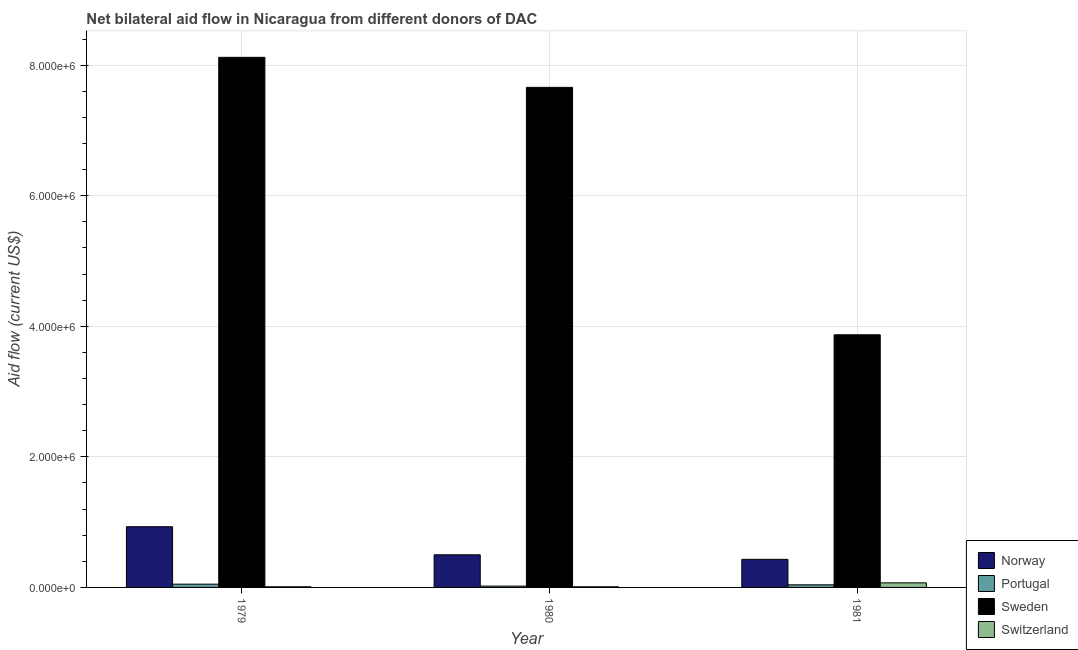Are the number of bars per tick equal to the number of legend labels?
Make the answer very short. Yes. Are the number of bars on each tick of the X-axis equal?
Provide a succinct answer. Yes. How many bars are there on the 1st tick from the left?
Keep it short and to the point. 4. How many bars are there on the 2nd tick from the right?
Keep it short and to the point. 4. What is the label of the 1st group of bars from the left?
Make the answer very short. 1979. In how many cases, is the number of bars for a given year not equal to the number of legend labels?
Provide a short and direct response. 0. What is the amount of aid given by sweden in 1979?
Ensure brevity in your answer.  8.12e+06. Across all years, what is the maximum amount of aid given by sweden?
Provide a short and direct response. 8.12e+06. Across all years, what is the minimum amount of aid given by switzerland?
Make the answer very short. 10000. What is the total amount of aid given by norway in the graph?
Ensure brevity in your answer.  1.86e+06. What is the difference between the amount of aid given by norway in 1979 and that in 1980?
Make the answer very short. 4.30e+05. What is the difference between the amount of aid given by norway in 1979 and the amount of aid given by portugal in 1981?
Make the answer very short. 5.00e+05. What is the average amount of aid given by norway per year?
Your response must be concise. 6.20e+05. In the year 1979, what is the difference between the amount of aid given by sweden and amount of aid given by switzerland?
Give a very brief answer. 0. In how many years, is the amount of aid given by switzerland greater than 7200000 US$?
Keep it short and to the point. 0. What is the ratio of the amount of aid given by portugal in 1979 to that in 1981?
Provide a succinct answer. 1.25. Is the amount of aid given by norway in 1980 less than that in 1981?
Offer a very short reply. No. Is the difference between the amount of aid given by portugal in 1980 and 1981 greater than the difference between the amount of aid given by switzerland in 1980 and 1981?
Give a very brief answer. No. What is the difference between the highest and the second highest amount of aid given by switzerland?
Your answer should be compact. 6.00e+04. What is the difference between the highest and the lowest amount of aid given by switzerland?
Your answer should be very brief. 6.00e+04. What does the 4th bar from the left in 1979 represents?
Your answer should be very brief. Switzerland. What does the 1st bar from the right in 1980 represents?
Ensure brevity in your answer.  Switzerland. How many bars are there?
Your response must be concise. 12. How many years are there in the graph?
Ensure brevity in your answer.  3. Does the graph contain grids?
Your response must be concise. Yes. How many legend labels are there?
Make the answer very short. 4. What is the title of the graph?
Your answer should be compact. Net bilateral aid flow in Nicaragua from different donors of DAC. Does "Public resource use" appear as one of the legend labels in the graph?
Your answer should be compact. No. What is the Aid flow (current US$) of Norway in 1979?
Your answer should be compact. 9.30e+05. What is the Aid flow (current US$) in Portugal in 1979?
Keep it short and to the point. 5.00e+04. What is the Aid flow (current US$) in Sweden in 1979?
Your response must be concise. 8.12e+06. What is the Aid flow (current US$) of Norway in 1980?
Give a very brief answer. 5.00e+05. What is the Aid flow (current US$) of Sweden in 1980?
Your answer should be compact. 7.66e+06. What is the Aid flow (current US$) of Portugal in 1981?
Your answer should be compact. 4.00e+04. What is the Aid flow (current US$) in Sweden in 1981?
Provide a succinct answer. 3.87e+06. Across all years, what is the maximum Aid flow (current US$) of Norway?
Make the answer very short. 9.30e+05. Across all years, what is the maximum Aid flow (current US$) of Sweden?
Provide a short and direct response. 8.12e+06. Across all years, what is the maximum Aid flow (current US$) in Switzerland?
Provide a succinct answer. 7.00e+04. Across all years, what is the minimum Aid flow (current US$) of Norway?
Offer a very short reply. 4.30e+05. Across all years, what is the minimum Aid flow (current US$) of Portugal?
Keep it short and to the point. 2.00e+04. Across all years, what is the minimum Aid flow (current US$) of Sweden?
Your answer should be very brief. 3.87e+06. Across all years, what is the minimum Aid flow (current US$) in Switzerland?
Your answer should be very brief. 10000. What is the total Aid flow (current US$) in Norway in the graph?
Ensure brevity in your answer.  1.86e+06. What is the total Aid flow (current US$) of Portugal in the graph?
Offer a terse response. 1.10e+05. What is the total Aid flow (current US$) in Sweden in the graph?
Ensure brevity in your answer.  1.96e+07. What is the difference between the Aid flow (current US$) of Norway in 1979 and that in 1980?
Your response must be concise. 4.30e+05. What is the difference between the Aid flow (current US$) in Sweden in 1979 and that in 1981?
Ensure brevity in your answer.  4.25e+06. What is the difference between the Aid flow (current US$) in Switzerland in 1979 and that in 1981?
Offer a terse response. -6.00e+04. What is the difference between the Aid flow (current US$) in Norway in 1980 and that in 1981?
Your answer should be very brief. 7.00e+04. What is the difference between the Aid flow (current US$) in Sweden in 1980 and that in 1981?
Your answer should be compact. 3.79e+06. What is the difference between the Aid flow (current US$) in Norway in 1979 and the Aid flow (current US$) in Portugal in 1980?
Your answer should be compact. 9.10e+05. What is the difference between the Aid flow (current US$) of Norway in 1979 and the Aid flow (current US$) of Sweden in 1980?
Your answer should be compact. -6.73e+06. What is the difference between the Aid flow (current US$) in Norway in 1979 and the Aid flow (current US$) in Switzerland in 1980?
Provide a succinct answer. 9.20e+05. What is the difference between the Aid flow (current US$) in Portugal in 1979 and the Aid flow (current US$) in Sweden in 1980?
Give a very brief answer. -7.61e+06. What is the difference between the Aid flow (current US$) in Portugal in 1979 and the Aid flow (current US$) in Switzerland in 1980?
Ensure brevity in your answer.  4.00e+04. What is the difference between the Aid flow (current US$) in Sweden in 1979 and the Aid flow (current US$) in Switzerland in 1980?
Ensure brevity in your answer.  8.11e+06. What is the difference between the Aid flow (current US$) of Norway in 1979 and the Aid flow (current US$) of Portugal in 1981?
Offer a terse response. 8.90e+05. What is the difference between the Aid flow (current US$) of Norway in 1979 and the Aid flow (current US$) of Sweden in 1981?
Your response must be concise. -2.94e+06. What is the difference between the Aid flow (current US$) in Norway in 1979 and the Aid flow (current US$) in Switzerland in 1981?
Your answer should be compact. 8.60e+05. What is the difference between the Aid flow (current US$) in Portugal in 1979 and the Aid flow (current US$) in Sweden in 1981?
Keep it short and to the point. -3.82e+06. What is the difference between the Aid flow (current US$) in Sweden in 1979 and the Aid flow (current US$) in Switzerland in 1981?
Offer a terse response. 8.05e+06. What is the difference between the Aid flow (current US$) of Norway in 1980 and the Aid flow (current US$) of Sweden in 1981?
Offer a terse response. -3.37e+06. What is the difference between the Aid flow (current US$) of Norway in 1980 and the Aid flow (current US$) of Switzerland in 1981?
Provide a succinct answer. 4.30e+05. What is the difference between the Aid flow (current US$) of Portugal in 1980 and the Aid flow (current US$) of Sweden in 1981?
Give a very brief answer. -3.85e+06. What is the difference between the Aid flow (current US$) of Portugal in 1980 and the Aid flow (current US$) of Switzerland in 1981?
Provide a short and direct response. -5.00e+04. What is the difference between the Aid flow (current US$) of Sweden in 1980 and the Aid flow (current US$) of Switzerland in 1981?
Your answer should be compact. 7.59e+06. What is the average Aid flow (current US$) of Norway per year?
Your answer should be compact. 6.20e+05. What is the average Aid flow (current US$) in Portugal per year?
Provide a short and direct response. 3.67e+04. What is the average Aid flow (current US$) of Sweden per year?
Your answer should be compact. 6.55e+06. In the year 1979, what is the difference between the Aid flow (current US$) in Norway and Aid flow (current US$) in Portugal?
Your answer should be very brief. 8.80e+05. In the year 1979, what is the difference between the Aid flow (current US$) of Norway and Aid flow (current US$) of Sweden?
Make the answer very short. -7.19e+06. In the year 1979, what is the difference between the Aid flow (current US$) of Norway and Aid flow (current US$) of Switzerland?
Make the answer very short. 9.20e+05. In the year 1979, what is the difference between the Aid flow (current US$) in Portugal and Aid flow (current US$) in Sweden?
Provide a succinct answer. -8.07e+06. In the year 1979, what is the difference between the Aid flow (current US$) of Sweden and Aid flow (current US$) of Switzerland?
Your answer should be compact. 8.11e+06. In the year 1980, what is the difference between the Aid flow (current US$) of Norway and Aid flow (current US$) of Portugal?
Provide a short and direct response. 4.80e+05. In the year 1980, what is the difference between the Aid flow (current US$) in Norway and Aid flow (current US$) in Sweden?
Offer a very short reply. -7.16e+06. In the year 1980, what is the difference between the Aid flow (current US$) of Portugal and Aid flow (current US$) of Sweden?
Give a very brief answer. -7.64e+06. In the year 1980, what is the difference between the Aid flow (current US$) of Sweden and Aid flow (current US$) of Switzerland?
Provide a succinct answer. 7.65e+06. In the year 1981, what is the difference between the Aid flow (current US$) of Norway and Aid flow (current US$) of Sweden?
Your answer should be compact. -3.44e+06. In the year 1981, what is the difference between the Aid flow (current US$) in Portugal and Aid flow (current US$) in Sweden?
Offer a terse response. -3.83e+06. In the year 1981, what is the difference between the Aid flow (current US$) in Portugal and Aid flow (current US$) in Switzerland?
Provide a succinct answer. -3.00e+04. In the year 1981, what is the difference between the Aid flow (current US$) of Sweden and Aid flow (current US$) of Switzerland?
Your answer should be very brief. 3.80e+06. What is the ratio of the Aid flow (current US$) of Norway in 1979 to that in 1980?
Provide a succinct answer. 1.86. What is the ratio of the Aid flow (current US$) of Sweden in 1979 to that in 1980?
Your answer should be very brief. 1.06. What is the ratio of the Aid flow (current US$) of Switzerland in 1979 to that in 1980?
Your response must be concise. 1. What is the ratio of the Aid flow (current US$) of Norway in 1979 to that in 1981?
Provide a succinct answer. 2.16. What is the ratio of the Aid flow (current US$) of Portugal in 1979 to that in 1981?
Provide a succinct answer. 1.25. What is the ratio of the Aid flow (current US$) in Sweden in 1979 to that in 1981?
Keep it short and to the point. 2.1. What is the ratio of the Aid flow (current US$) of Switzerland in 1979 to that in 1981?
Keep it short and to the point. 0.14. What is the ratio of the Aid flow (current US$) of Norway in 1980 to that in 1981?
Your response must be concise. 1.16. What is the ratio of the Aid flow (current US$) of Portugal in 1980 to that in 1981?
Give a very brief answer. 0.5. What is the ratio of the Aid flow (current US$) in Sweden in 1980 to that in 1981?
Offer a terse response. 1.98. What is the ratio of the Aid flow (current US$) in Switzerland in 1980 to that in 1981?
Your answer should be compact. 0.14. What is the difference between the highest and the second highest Aid flow (current US$) in Norway?
Provide a succinct answer. 4.30e+05. What is the difference between the highest and the second highest Aid flow (current US$) of Sweden?
Provide a succinct answer. 4.60e+05. What is the difference between the highest and the second highest Aid flow (current US$) of Switzerland?
Offer a very short reply. 6.00e+04. What is the difference between the highest and the lowest Aid flow (current US$) in Norway?
Your response must be concise. 5.00e+05. What is the difference between the highest and the lowest Aid flow (current US$) in Portugal?
Your answer should be compact. 3.00e+04. What is the difference between the highest and the lowest Aid flow (current US$) in Sweden?
Offer a very short reply. 4.25e+06. What is the difference between the highest and the lowest Aid flow (current US$) in Switzerland?
Your response must be concise. 6.00e+04. 